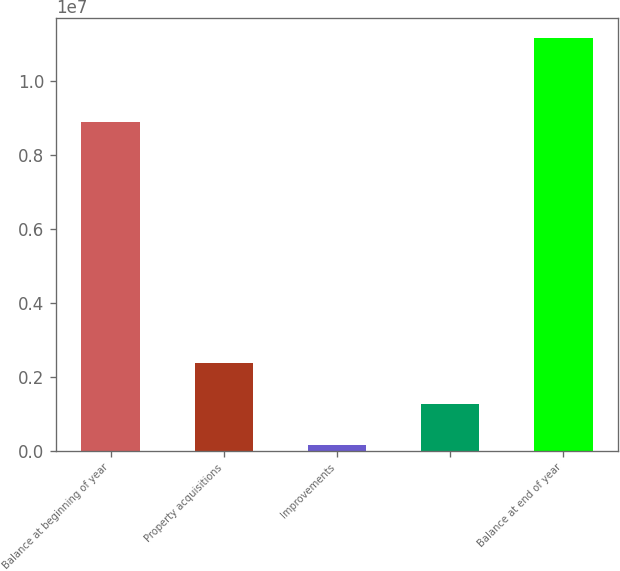Convert chart to OTSL. <chart><loc_0><loc_0><loc_500><loc_500><bar_chart><fcel>Balance at beginning of year<fcel>Property acquisitions<fcel>Improvements<fcel>Unnamed: 3<fcel>Balance at end of year<nl><fcel>8.89006e+06<fcel>2.35973e+06<fcel>162875<fcel>1.2613e+06<fcel>1.11472e+07<nl></chart> 